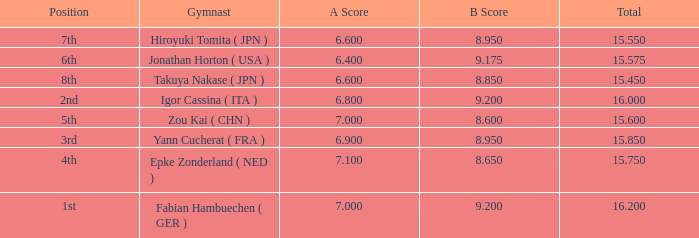Which gymnast had a b score of 8.95 and an a score less than 6.9 Hiroyuki Tomita ( JPN ). 